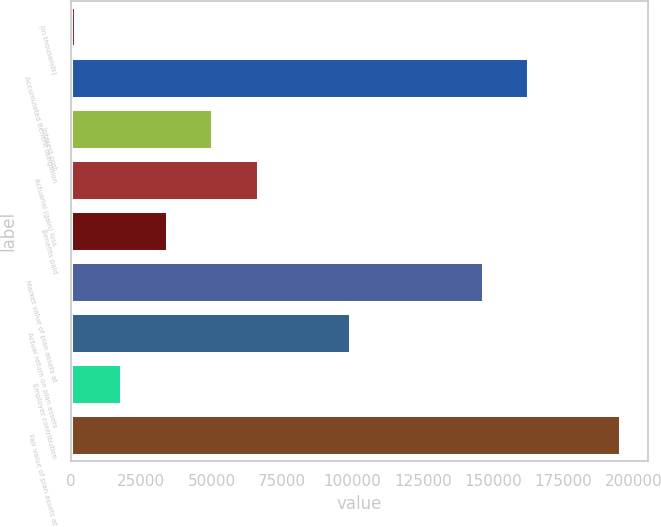<chart> <loc_0><loc_0><loc_500><loc_500><bar_chart><fcel>(in thousands)<fcel>Accumulated Benefit obligation<fcel>Interest cost<fcel>Actuarial (gain) loss<fcel>Benefits paid<fcel>Market value of plan assets at<fcel>Actual return on plan assets<fcel>Employer contribution<fcel>Fair value of plan assets at<nl><fcel>2007<fcel>162885<fcel>50705.4<fcel>66938.2<fcel>34472.6<fcel>146652<fcel>99403.8<fcel>18239.8<fcel>195350<nl></chart> 